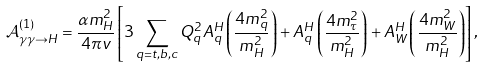<formula> <loc_0><loc_0><loc_500><loc_500>\mathcal { A } ^ { \left ( 1 \right ) } _ { \gamma \gamma \rightarrow H } = \frac { \alpha m _ { H } ^ { 2 } } { 4 \pi v } \left [ 3 \sum _ { q = t , b , c } Q _ { q } ^ { 2 } A _ { q } ^ { H } \left ( \frac { 4 m _ { q } ^ { 2 } } { m _ { H } ^ { 2 } } \right ) + A _ { q } ^ { H } \left ( \frac { 4 m _ { \tau } ^ { 2 } } { m _ { H } ^ { 2 } } \right ) + A _ { W } ^ { H } \left ( \frac { 4 m _ { W } ^ { 2 } } { m _ { H } ^ { 2 } } \right ) \right ] ,</formula> 